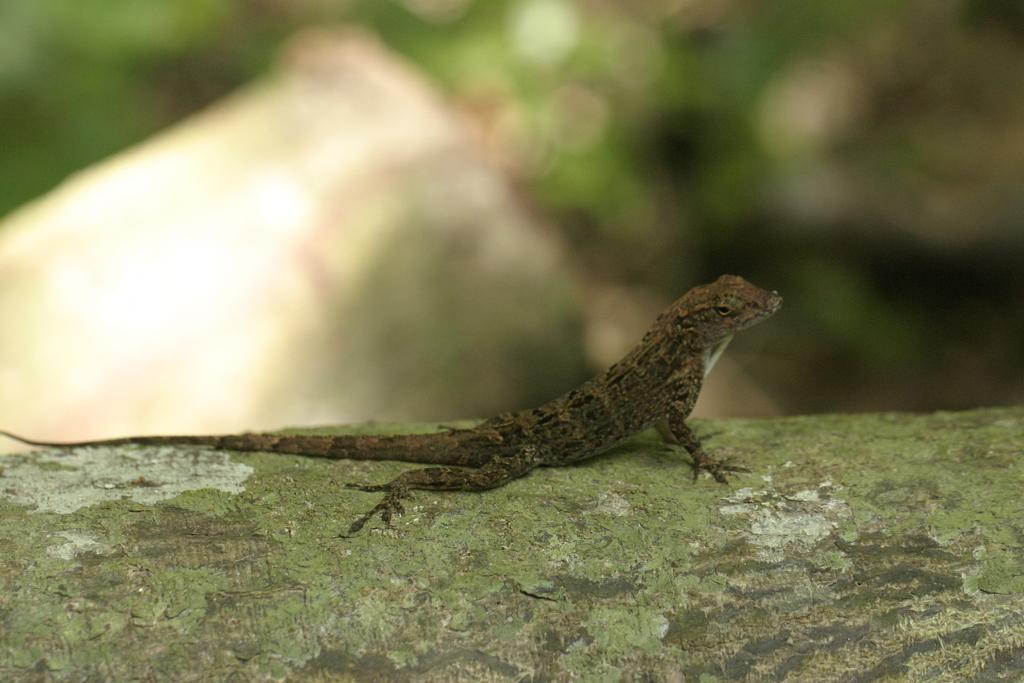What type of animal is in the image? There is a reptile in the image. What is the reptile resting on? The reptile is on a wooden surface. Can you describe the background of the image? The background of the image is blurred. How is the reptile using the glue in the image? There is no glue present in the image, and therefore the reptile cannot be using it. 